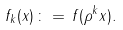<formula> <loc_0><loc_0><loc_500><loc_500>f _ { k } ( x ) \, \colon = \, f ( \rho ^ { k } x ) .</formula> 